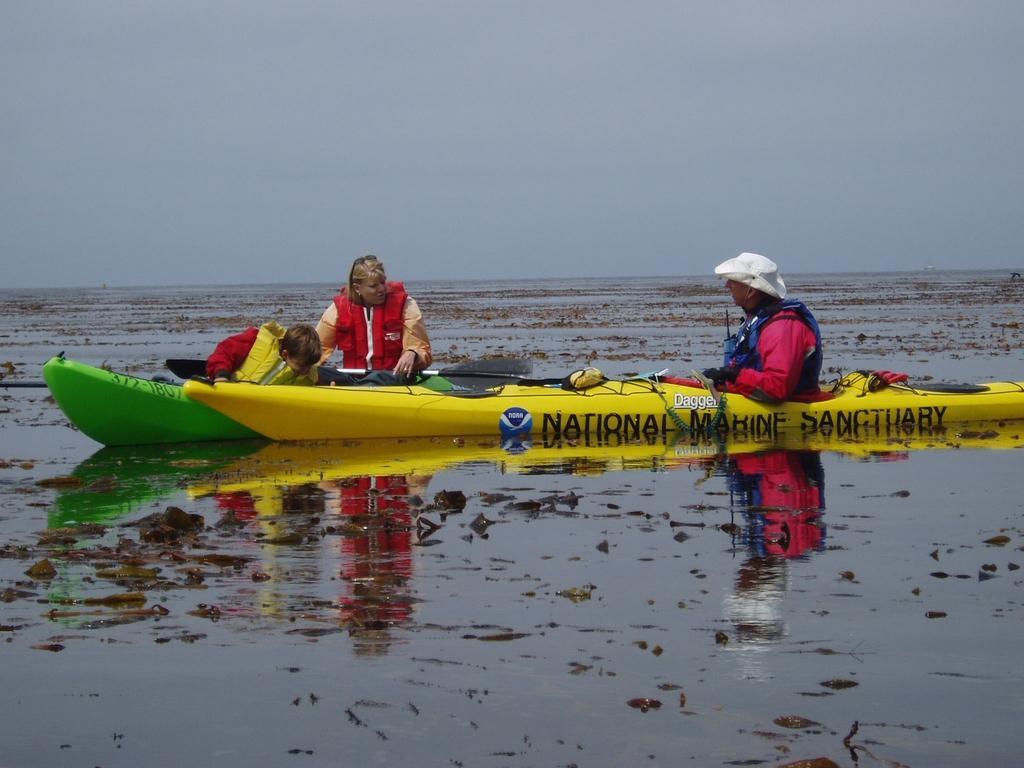In one or two sentences, can you explain what this image depicts? At the bottom of the image on the water there are kayaks. There are three persons sitting in the kayaks. There is a man with a hat on his head. At the top of the image there is sky. 